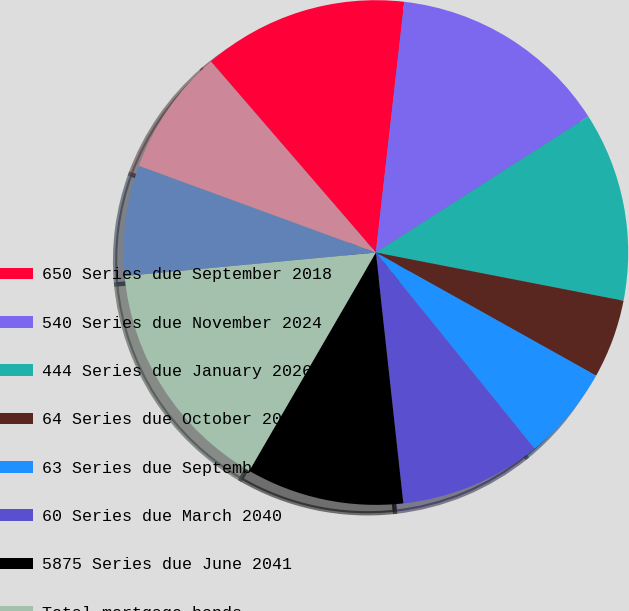Convert chart to OTSL. <chart><loc_0><loc_0><loc_500><loc_500><pie_chart><fcel>650 Series due September 2018<fcel>540 Series due November 2024<fcel>444 Series due January 2026<fcel>64 Series due October 2034<fcel>63 Series due September 2035<fcel>60 Series due March 2040<fcel>5875 Series due June 2041<fcel>Total mortgage bonds<fcel>50 Series due 2030 Louisiana<fcel>Total governmental bonds<nl><fcel>13.13%<fcel>14.14%<fcel>12.12%<fcel>5.05%<fcel>6.06%<fcel>9.09%<fcel>10.1%<fcel>15.15%<fcel>7.07%<fcel>8.08%<nl></chart> 